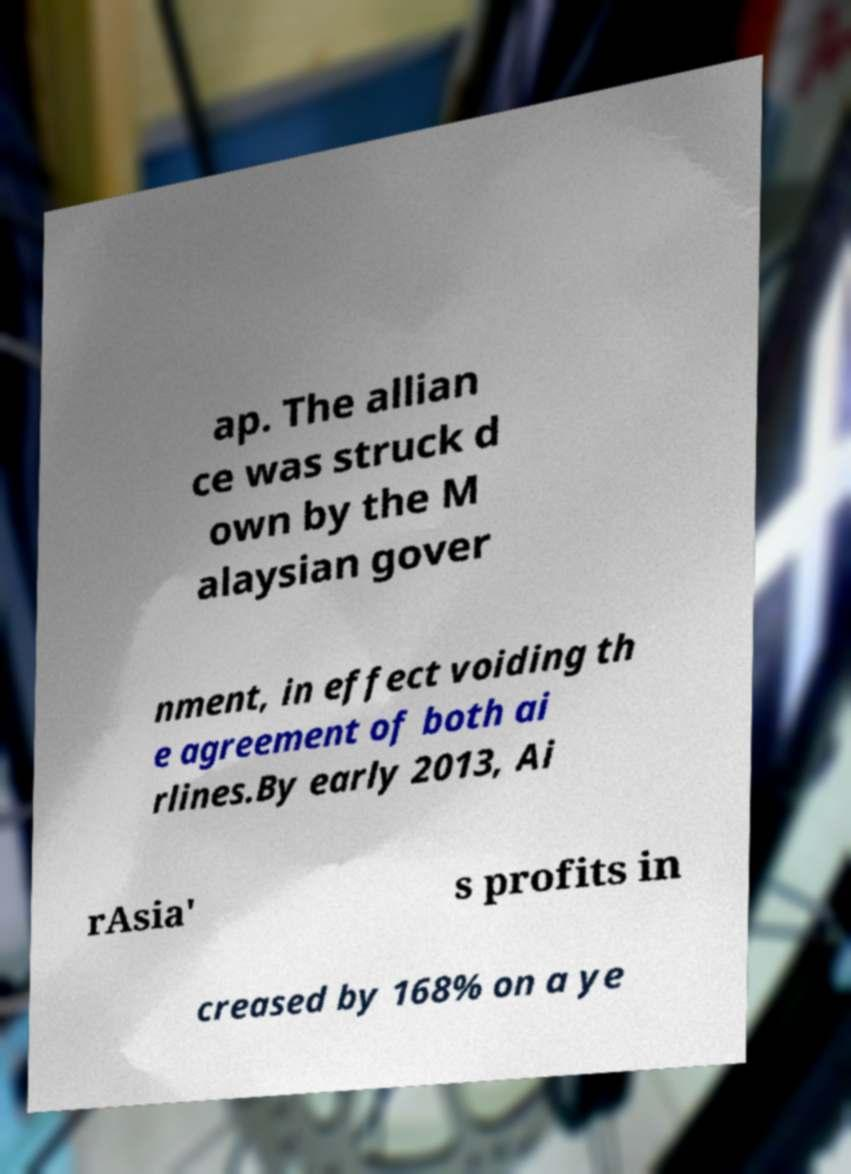Can you accurately transcribe the text from the provided image for me? ap. The allian ce was struck d own by the M alaysian gover nment, in effect voiding th e agreement of both ai rlines.By early 2013, Ai rAsia' s profits in creased by 168% on a ye 